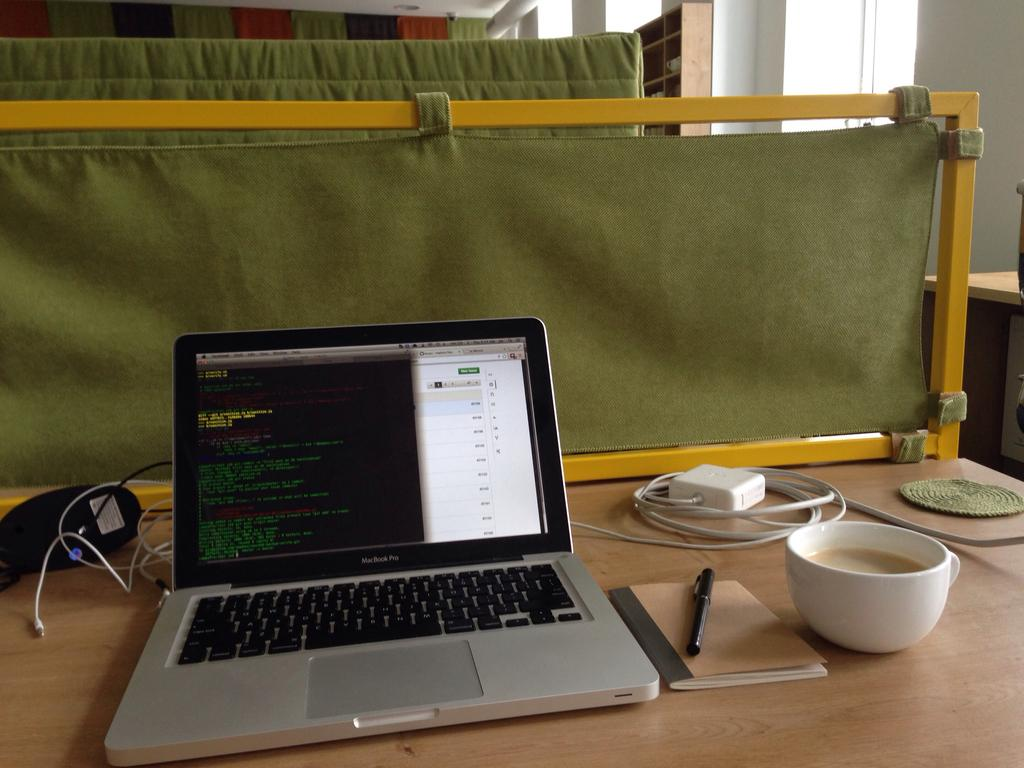What electronic device is on the table in the image? There is a laptop on the table in the image. What else can be seen on the table besides the laptop? There is a book, a pen, a cup, and a wire on the table in the image. What can be seen in the background of the image? There is a wall and a cloth in the background of the image. What type of stew is being prepared on the table in the image? There is no stew present in the image; the items on the table are a laptop, a book, a pen, a cup, and a wire. Can you see a lake in the background of the image? There is no lake visible in the image; the background features a wall and a cloth. 